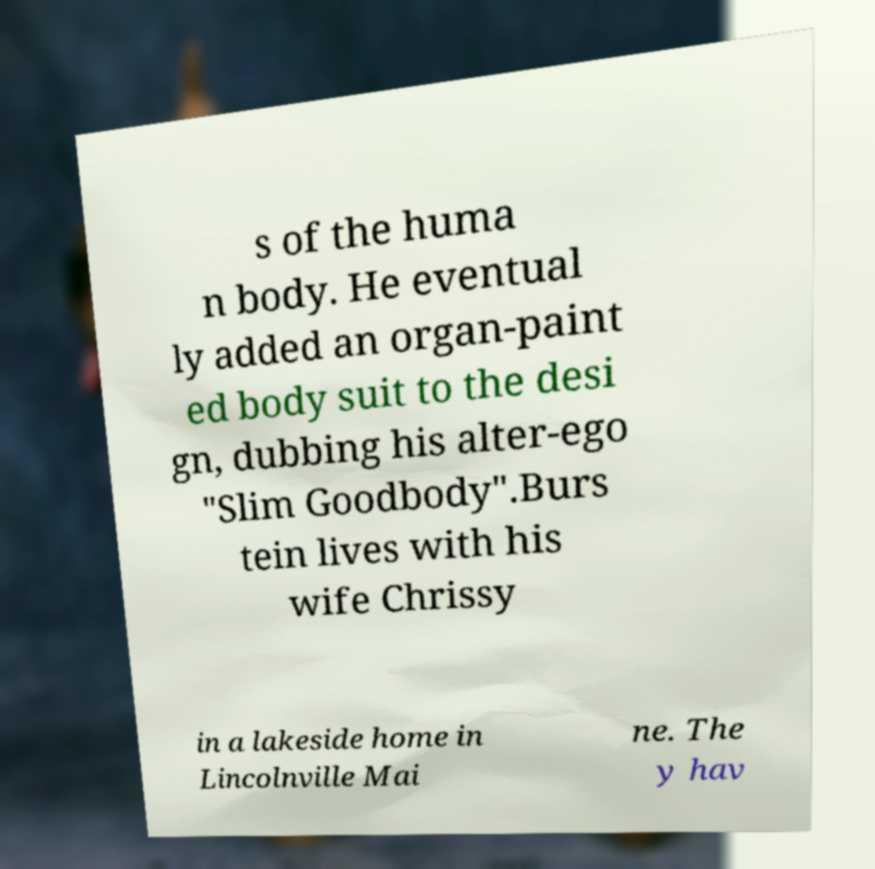What messages or text are displayed in this image? I need them in a readable, typed format. s of the huma n body. He eventual ly added an organ-paint ed body suit to the desi gn, dubbing his alter-ego "Slim Goodbody".Burs tein lives with his wife Chrissy in a lakeside home in Lincolnville Mai ne. The y hav 